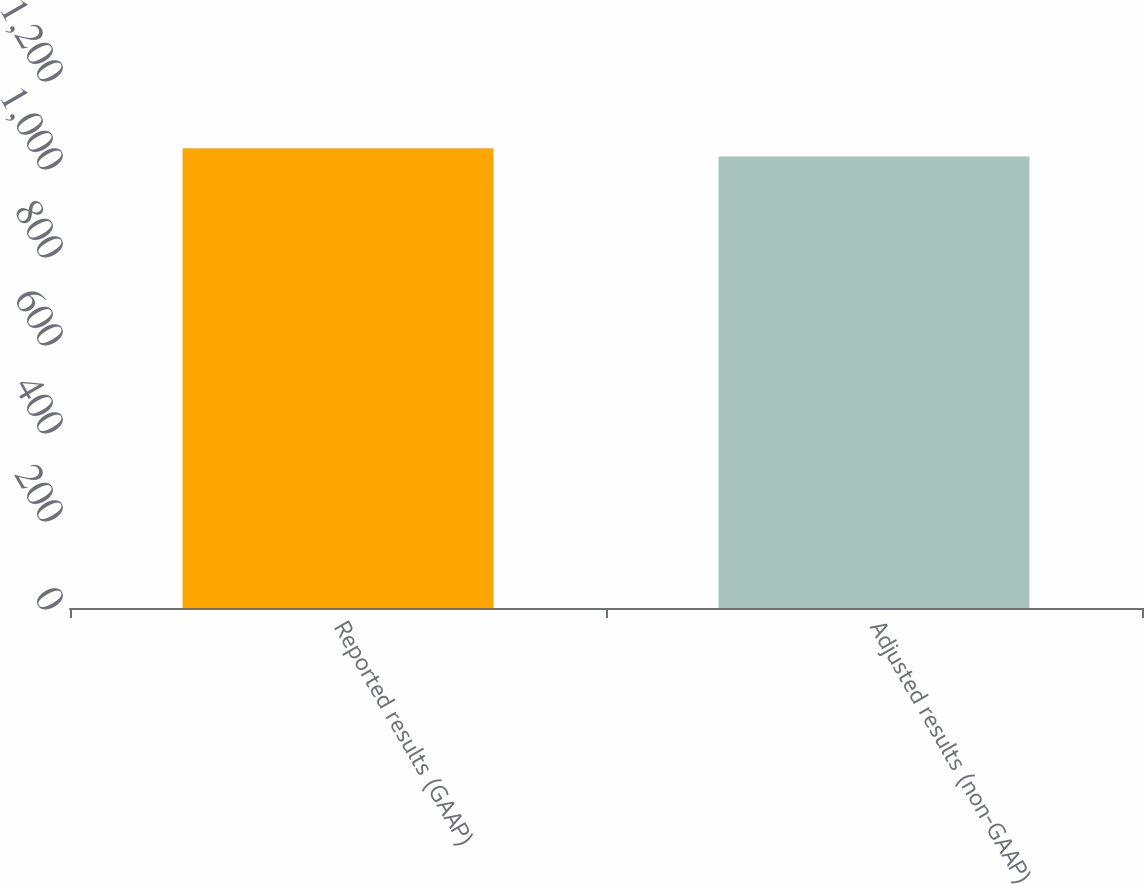<chart> <loc_0><loc_0><loc_500><loc_500><bar_chart><fcel>Reported results (GAAP)<fcel>Adjusted results (non-GAAP)<nl><fcel>1045<fcel>1026<nl></chart> 